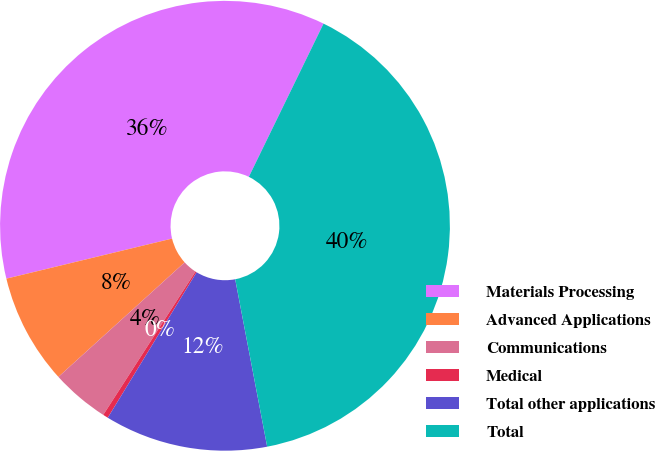Convert chart. <chart><loc_0><loc_0><loc_500><loc_500><pie_chart><fcel>Materials Processing<fcel>Advanced Applications<fcel>Communications<fcel>Medical<fcel>Total other applications<fcel>Total<nl><fcel>36.0%<fcel>7.95%<fcel>4.17%<fcel>0.38%<fcel>11.73%<fcel>39.78%<nl></chart> 